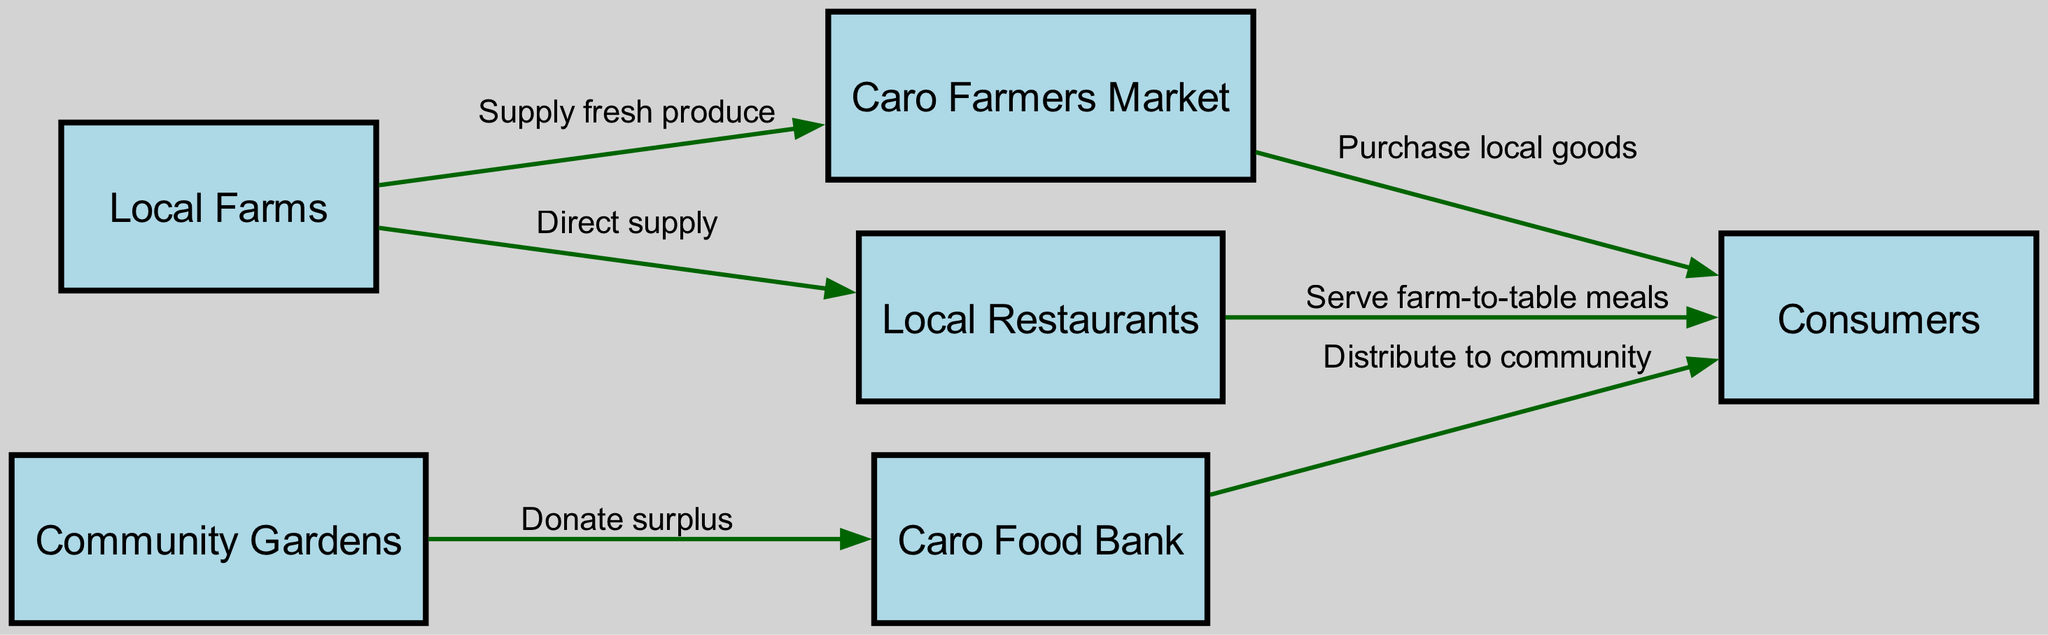What are the main sources of fresh produce in Caro? The diagram indicates that "Local Farms" are the main sources supplying fresh produce to both the "Caro Farmers Market" and "Local Restaurants."
Answer: Local Farms How many nodes are in the diagram? Upon counting the nodes listed in the diagram, there are six distinct entities represented: Local Farms, Caro Farmers Market, Community Gardens, Local Restaurants, Caro Food Bank, and Consumers.
Answer: 6 What is the relationship between Local Farms and Caro Farmers Market? The diagram shows an edge connecting "Local Farms" to "Caro Farmers Market" labeled "Supply fresh produce," indicating a direct supply relationship.
Answer: Supply fresh produce Who does the Caro Food Bank distribute food to? The diagram illustrates that the "Caro Food Bank" has a line leading to "Consumers," indicating that it distributes food to the local community or consumers in Caro.
Answer: Consumers Which node is associated with donating surplus food? The diagram indicates that "Community Gardens" has a directed edge leading to "Caro Food Bank" labeled "Donate surplus," showing its role in surplus food donation.
Answer: Community Gardens What action do local restaurants take with the food they receive? The diagram shows that "Local Restaurants" serve farm-to-table meals as indicated by the edge connecting it to "Consumers," meaning they prepare and serve meals using locally sourced ingredients.
Answer: Serve farm-to-table meals Which node connects to both Local Farms and Community Gardens? Looking at the diagram, the "Caro Food Bank" connects with both "Local Farms" (through surplus supply) and "Community Gardens" (through food donation), indicating its role in the food chain.
Answer: Caro Food Bank How do consumers obtain food from the Caro Farmers Market? The diagram shows a direct edge from "Caro Farmers Market" to "Consumers" labeled "Purchase local goods," indicating that consumers acquire food through purchasing.
Answer: Purchase local goods What is one way Community Gardens contribute to the food chain in Caro? The diagram states that "Community Gardens" contribute by donating surplus food to the "Caro Food Bank," helping to reduce waste and support the community.
Answer: Donate surplus 